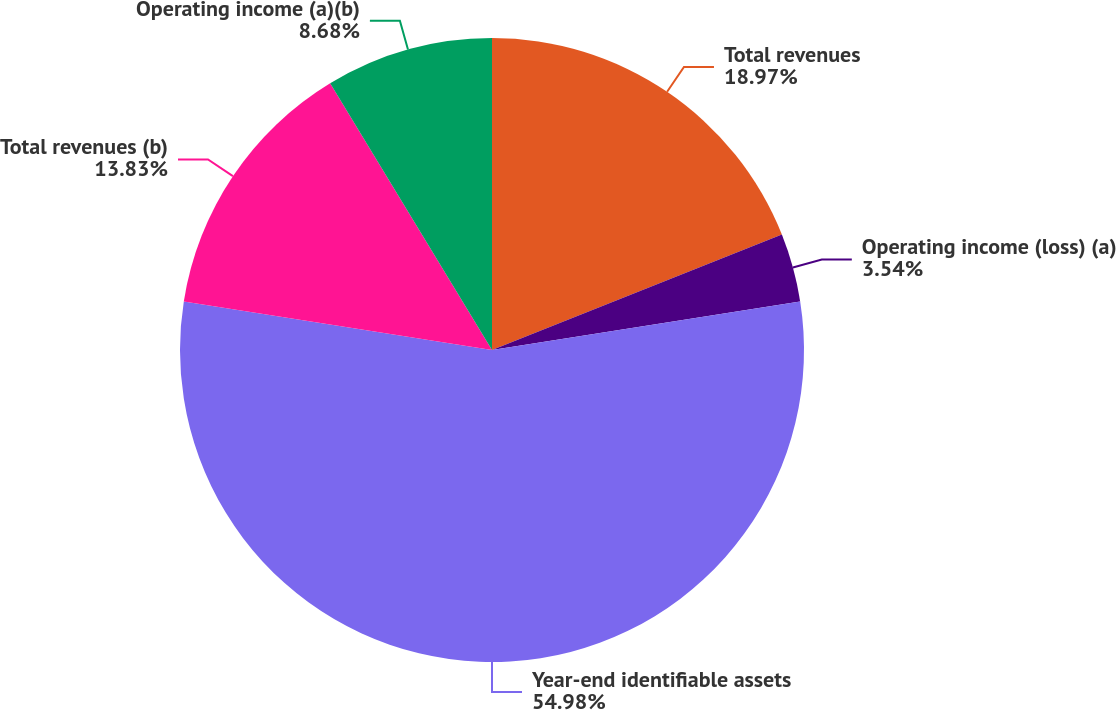<chart> <loc_0><loc_0><loc_500><loc_500><pie_chart><fcel>Total revenues<fcel>Operating income (loss) (a)<fcel>Year-end identifiable assets<fcel>Total revenues (b)<fcel>Operating income (a)(b)<nl><fcel>18.97%<fcel>3.54%<fcel>54.98%<fcel>13.83%<fcel>8.68%<nl></chart> 